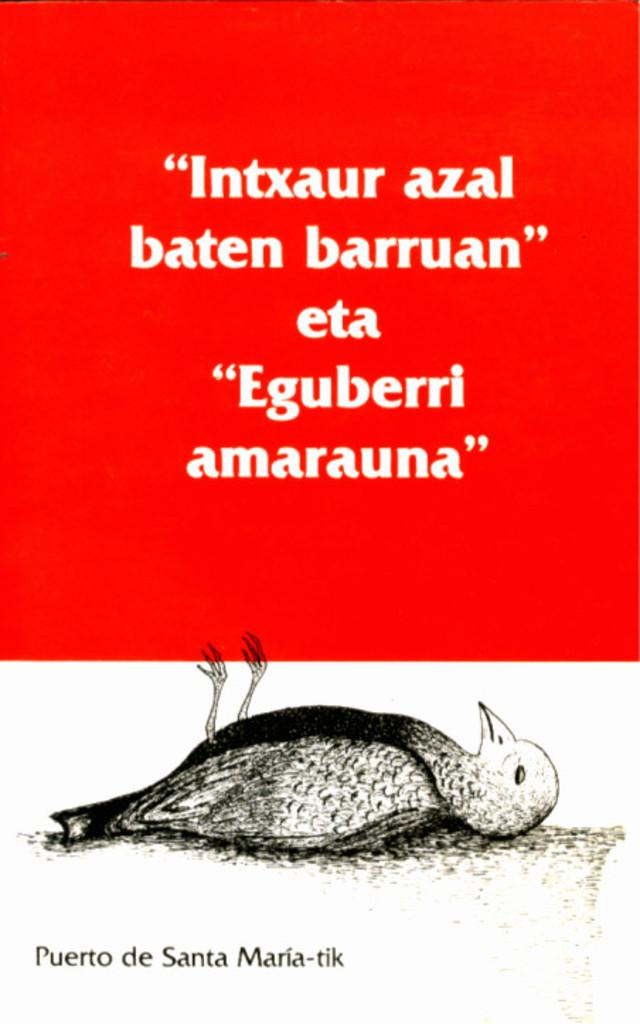What is present in the image? There is a poster in the image. What can be seen on the poster? The poster contains an image of a bird. How does the growth of the fish affect the lamp in the image? There is no fish or lamp present in the image; it only contains a poster with an image of a bird. 